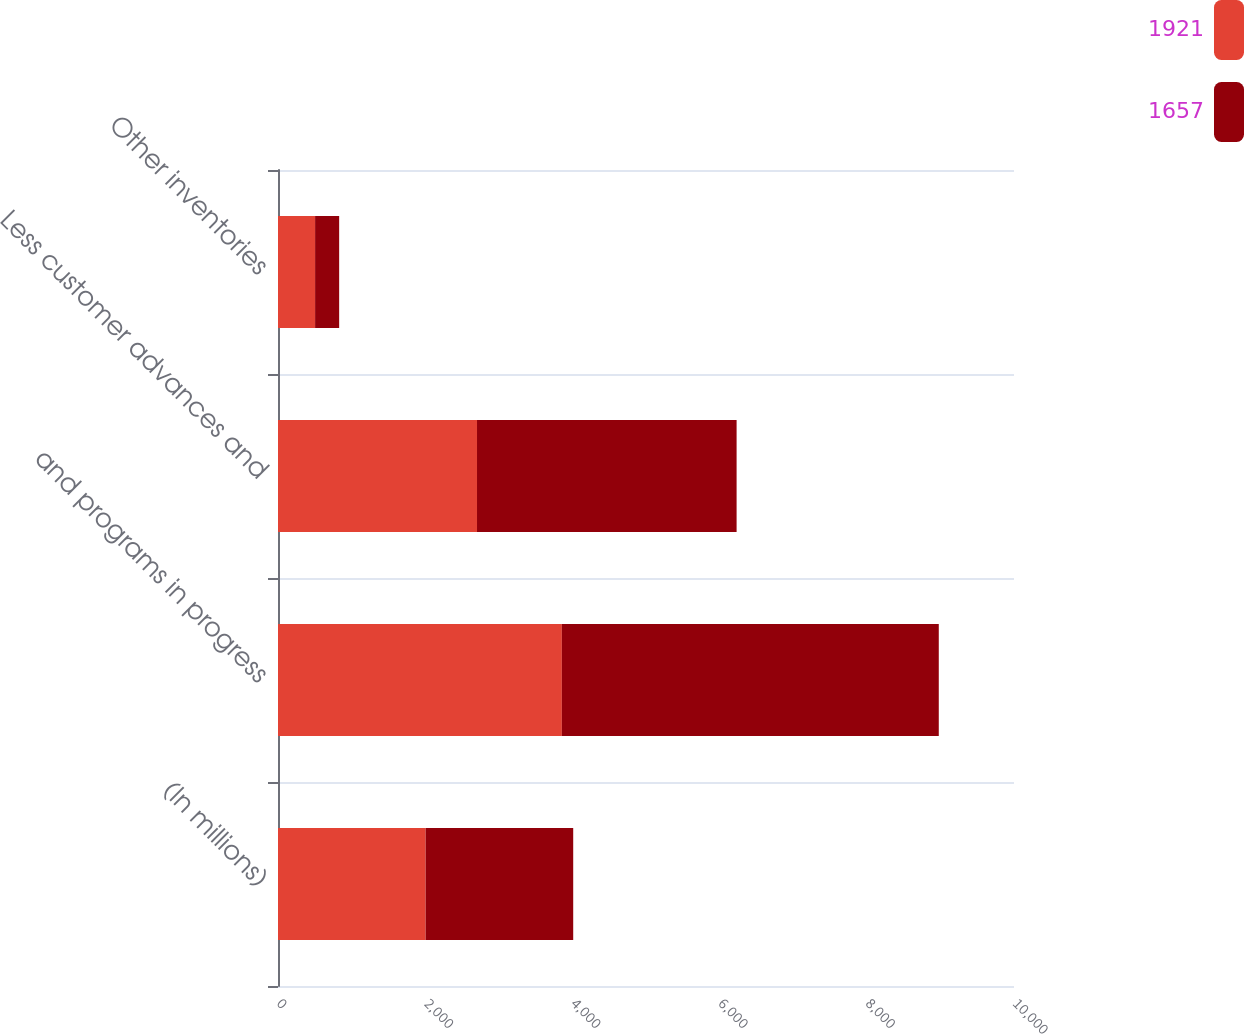Convert chart to OTSL. <chart><loc_0><loc_0><loc_500><loc_500><stacked_bar_chart><ecel><fcel>(In millions)<fcel>and programs in progress<fcel>Less customer advances and<fcel>Other inventories<nl><fcel>1921<fcel>2006<fcel>3857<fcel>2704<fcel>504<nl><fcel>1657<fcel>2005<fcel>5121<fcel>3527<fcel>327<nl></chart> 